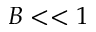Convert formula to latex. <formula><loc_0><loc_0><loc_500><loc_500>B < < 1</formula> 